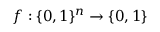<formula> <loc_0><loc_0><loc_500><loc_500>f \colon \{ 0 , 1 \} ^ { n } \rightarrow \{ 0 , 1 \}</formula> 